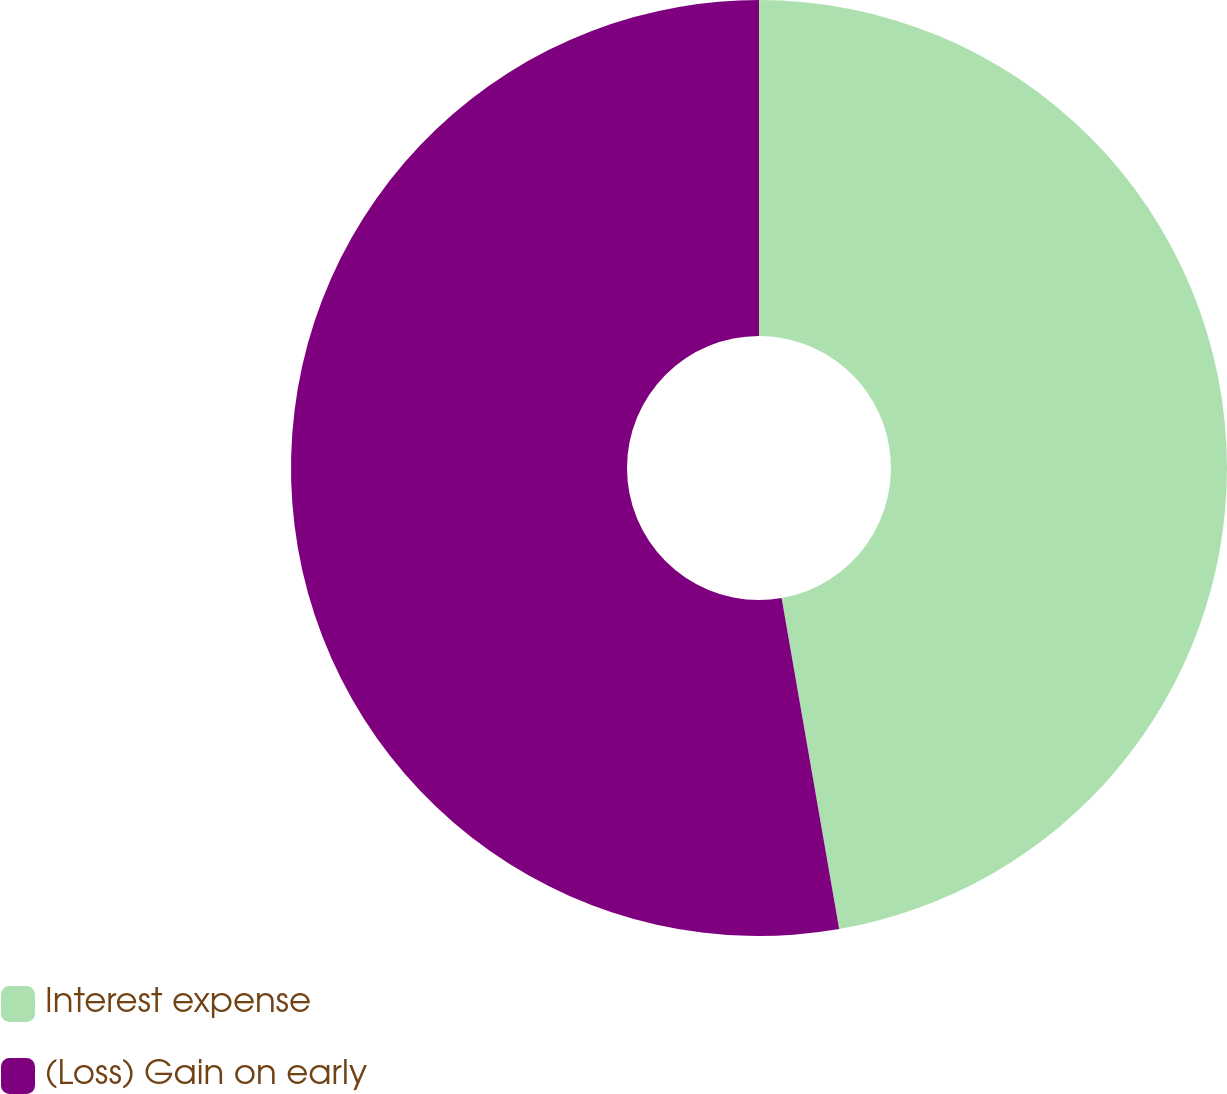<chart> <loc_0><loc_0><loc_500><loc_500><pie_chart><fcel>Interest expense<fcel>(Loss) Gain on early<nl><fcel>47.26%<fcel>52.74%<nl></chart> 